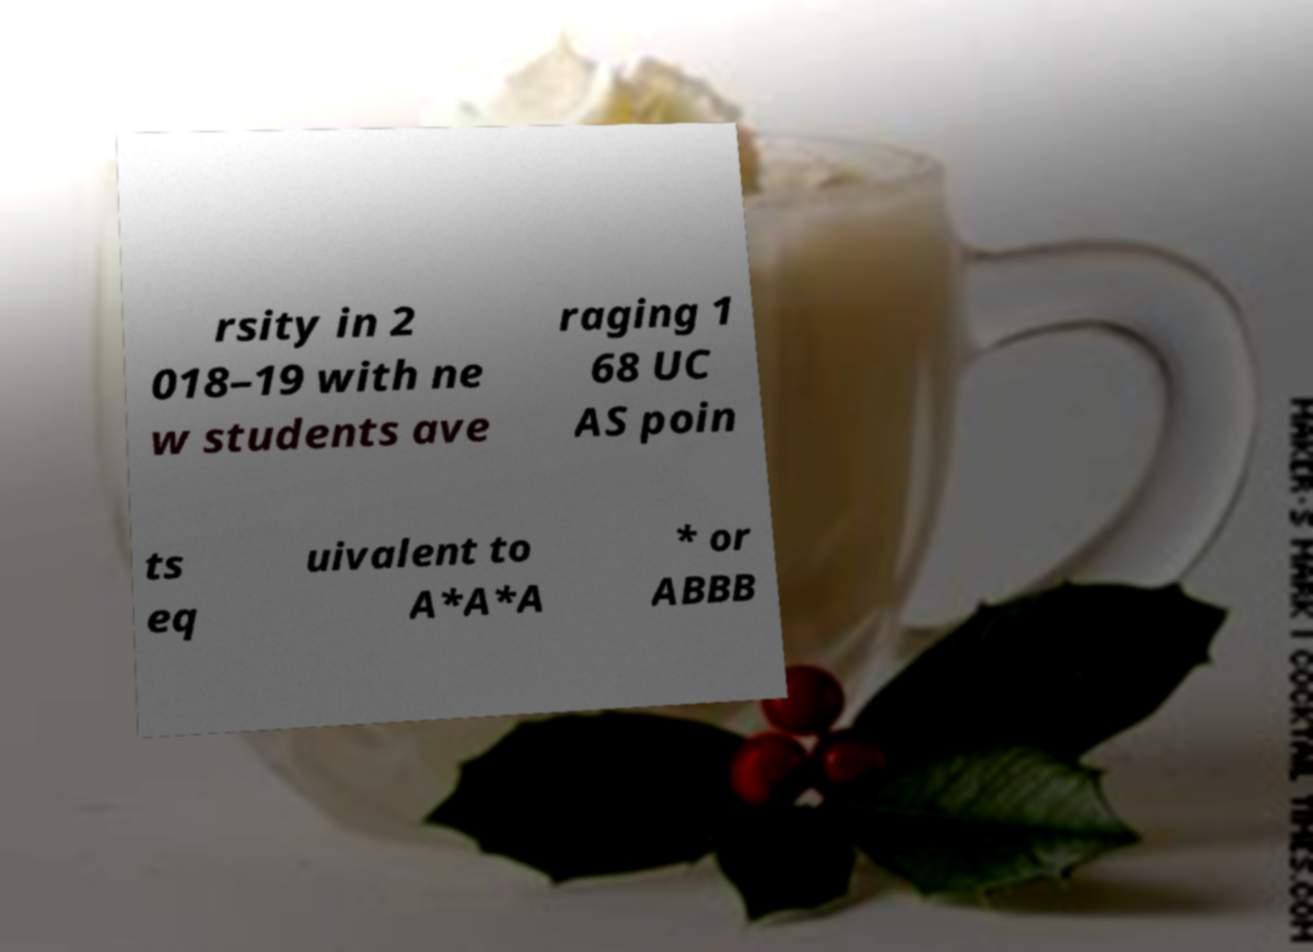I need the written content from this picture converted into text. Can you do that? rsity in 2 018–19 with ne w students ave raging 1 68 UC AS poin ts eq uivalent to A*A*A * or ABBB 